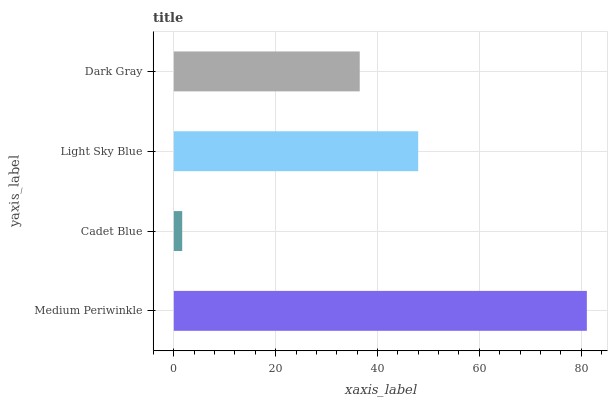Is Cadet Blue the minimum?
Answer yes or no. Yes. Is Medium Periwinkle the maximum?
Answer yes or no. Yes. Is Light Sky Blue the minimum?
Answer yes or no. No. Is Light Sky Blue the maximum?
Answer yes or no. No. Is Light Sky Blue greater than Cadet Blue?
Answer yes or no. Yes. Is Cadet Blue less than Light Sky Blue?
Answer yes or no. Yes. Is Cadet Blue greater than Light Sky Blue?
Answer yes or no. No. Is Light Sky Blue less than Cadet Blue?
Answer yes or no. No. Is Light Sky Blue the high median?
Answer yes or no. Yes. Is Dark Gray the low median?
Answer yes or no. Yes. Is Dark Gray the high median?
Answer yes or no. No. Is Cadet Blue the low median?
Answer yes or no. No. 